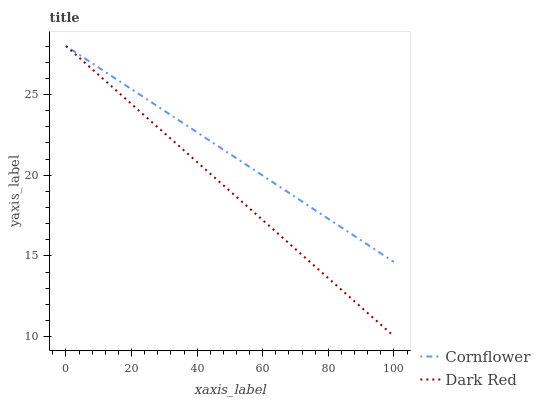Does Dark Red have the minimum area under the curve?
Answer yes or no. Yes. Does Cornflower have the maximum area under the curve?
Answer yes or no. Yes. Does Dark Red have the maximum area under the curve?
Answer yes or no. No. Is Dark Red the smoothest?
Answer yes or no. Yes. Is Cornflower the roughest?
Answer yes or no. Yes. Is Dark Red the roughest?
Answer yes or no. No. Does Dark Red have the lowest value?
Answer yes or no. Yes. Does Dark Red have the highest value?
Answer yes or no. Yes. Does Cornflower intersect Dark Red?
Answer yes or no. Yes. Is Cornflower less than Dark Red?
Answer yes or no. No. Is Cornflower greater than Dark Red?
Answer yes or no. No. 